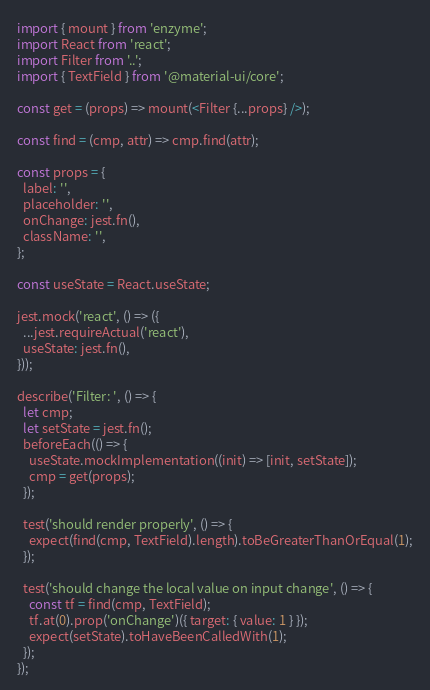<code> <loc_0><loc_0><loc_500><loc_500><_JavaScript_>import { mount } from 'enzyme';
import React from 'react';
import Filter from '..';
import { TextField } from '@material-ui/core';

const get = (props) => mount(<Filter {...props} />);

const find = (cmp, attr) => cmp.find(attr);

const props = {
  label: '',
  placeholder: '',
  onChange: jest.fn(),
  className: '',
};

const useState = React.useState;

jest.mock('react', () => ({
  ...jest.requireActual('react'),
  useState: jest.fn(),
}));

describe('Filter: ', () => {
  let cmp;
  let setState = jest.fn();
  beforeEach(() => {
    useState.mockImplementation((init) => [init, setState]);
    cmp = get(props);
  });

  test('should render properly', () => {
    expect(find(cmp, TextField).length).toBeGreaterThanOrEqual(1);
  });

  test('should change the local value on input change', () => {
    const tf = find(cmp, TextField);
    tf.at(0).prop('onChange')({ target: { value: 1 } });
    expect(setState).toHaveBeenCalledWith(1);
  });
});
</code> 